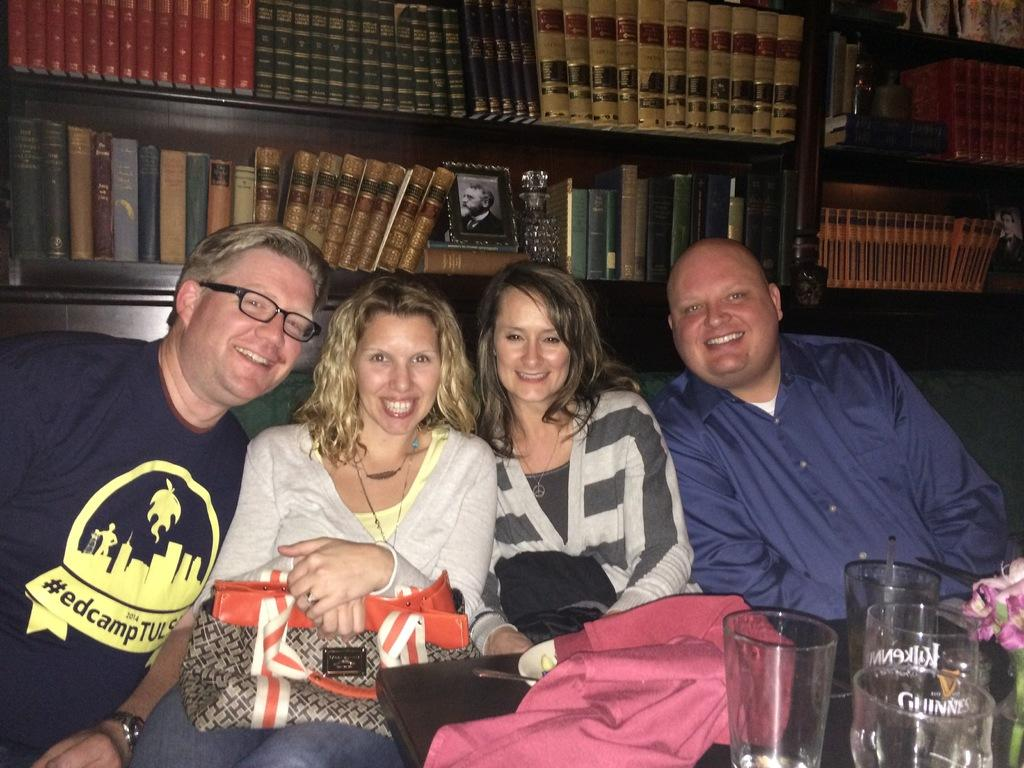How many people are in the image? There are four persons in the image. What is the facial expression of the persons in the image? The persons are smiling. What are the persons doing in the image? The persons are sitting. What can be seen in the background of the image? There are many books in a rack in the background of the image. What objects are present in the image besides the persons? There is a flower vase and glasses in the image. What type of quill is being used by the person in the image? There is no quill present in the image. What are the persons reading in the image? The provided facts do not mention any reading activity in the image. 